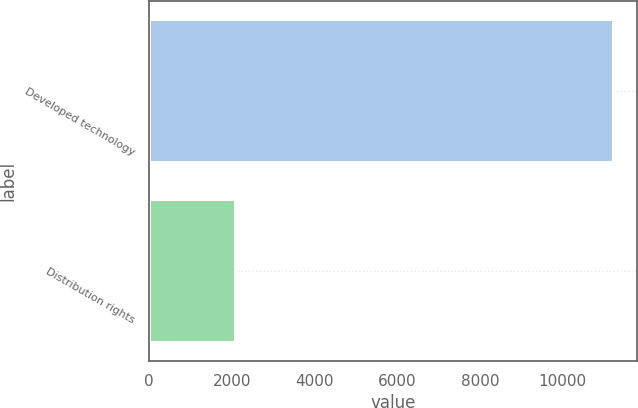Convert chart to OTSL. <chart><loc_0><loc_0><loc_500><loc_500><bar_chart><fcel>Developed technology<fcel>Distribution rights<nl><fcel>11242<fcel>2109<nl></chart> 